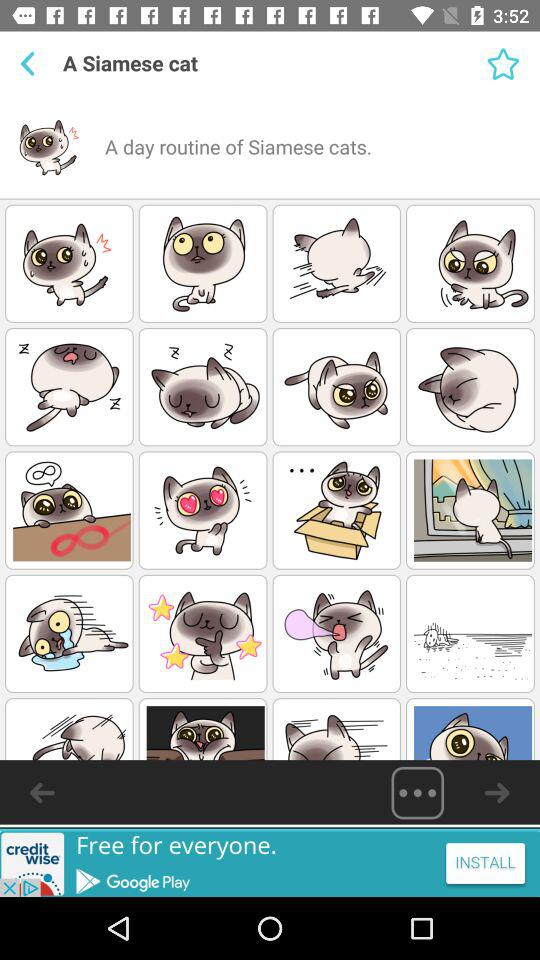What is the name of the application?
When the provided information is insufficient, respond with <no answer>. <no answer> 